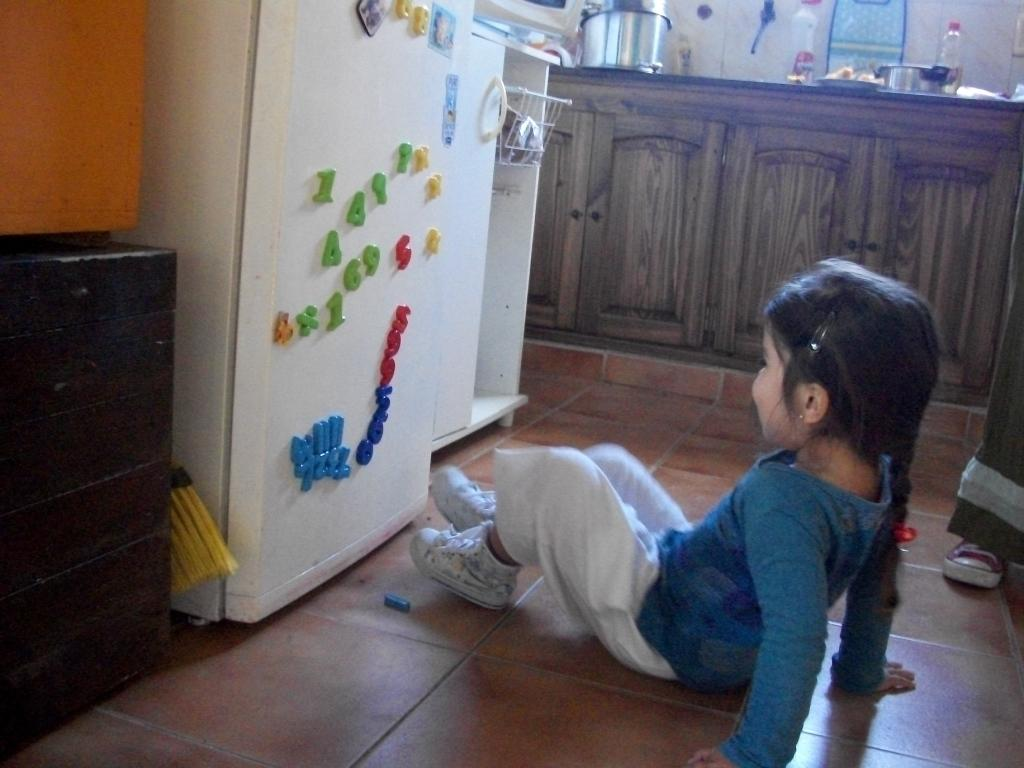<image>
Summarize the visual content of the image. A girl sitting in front of the fridge with a variety of magnets including 1, 6, 9, A and X. 